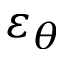<formula> <loc_0><loc_0><loc_500><loc_500>\varepsilon _ { \theta }</formula> 